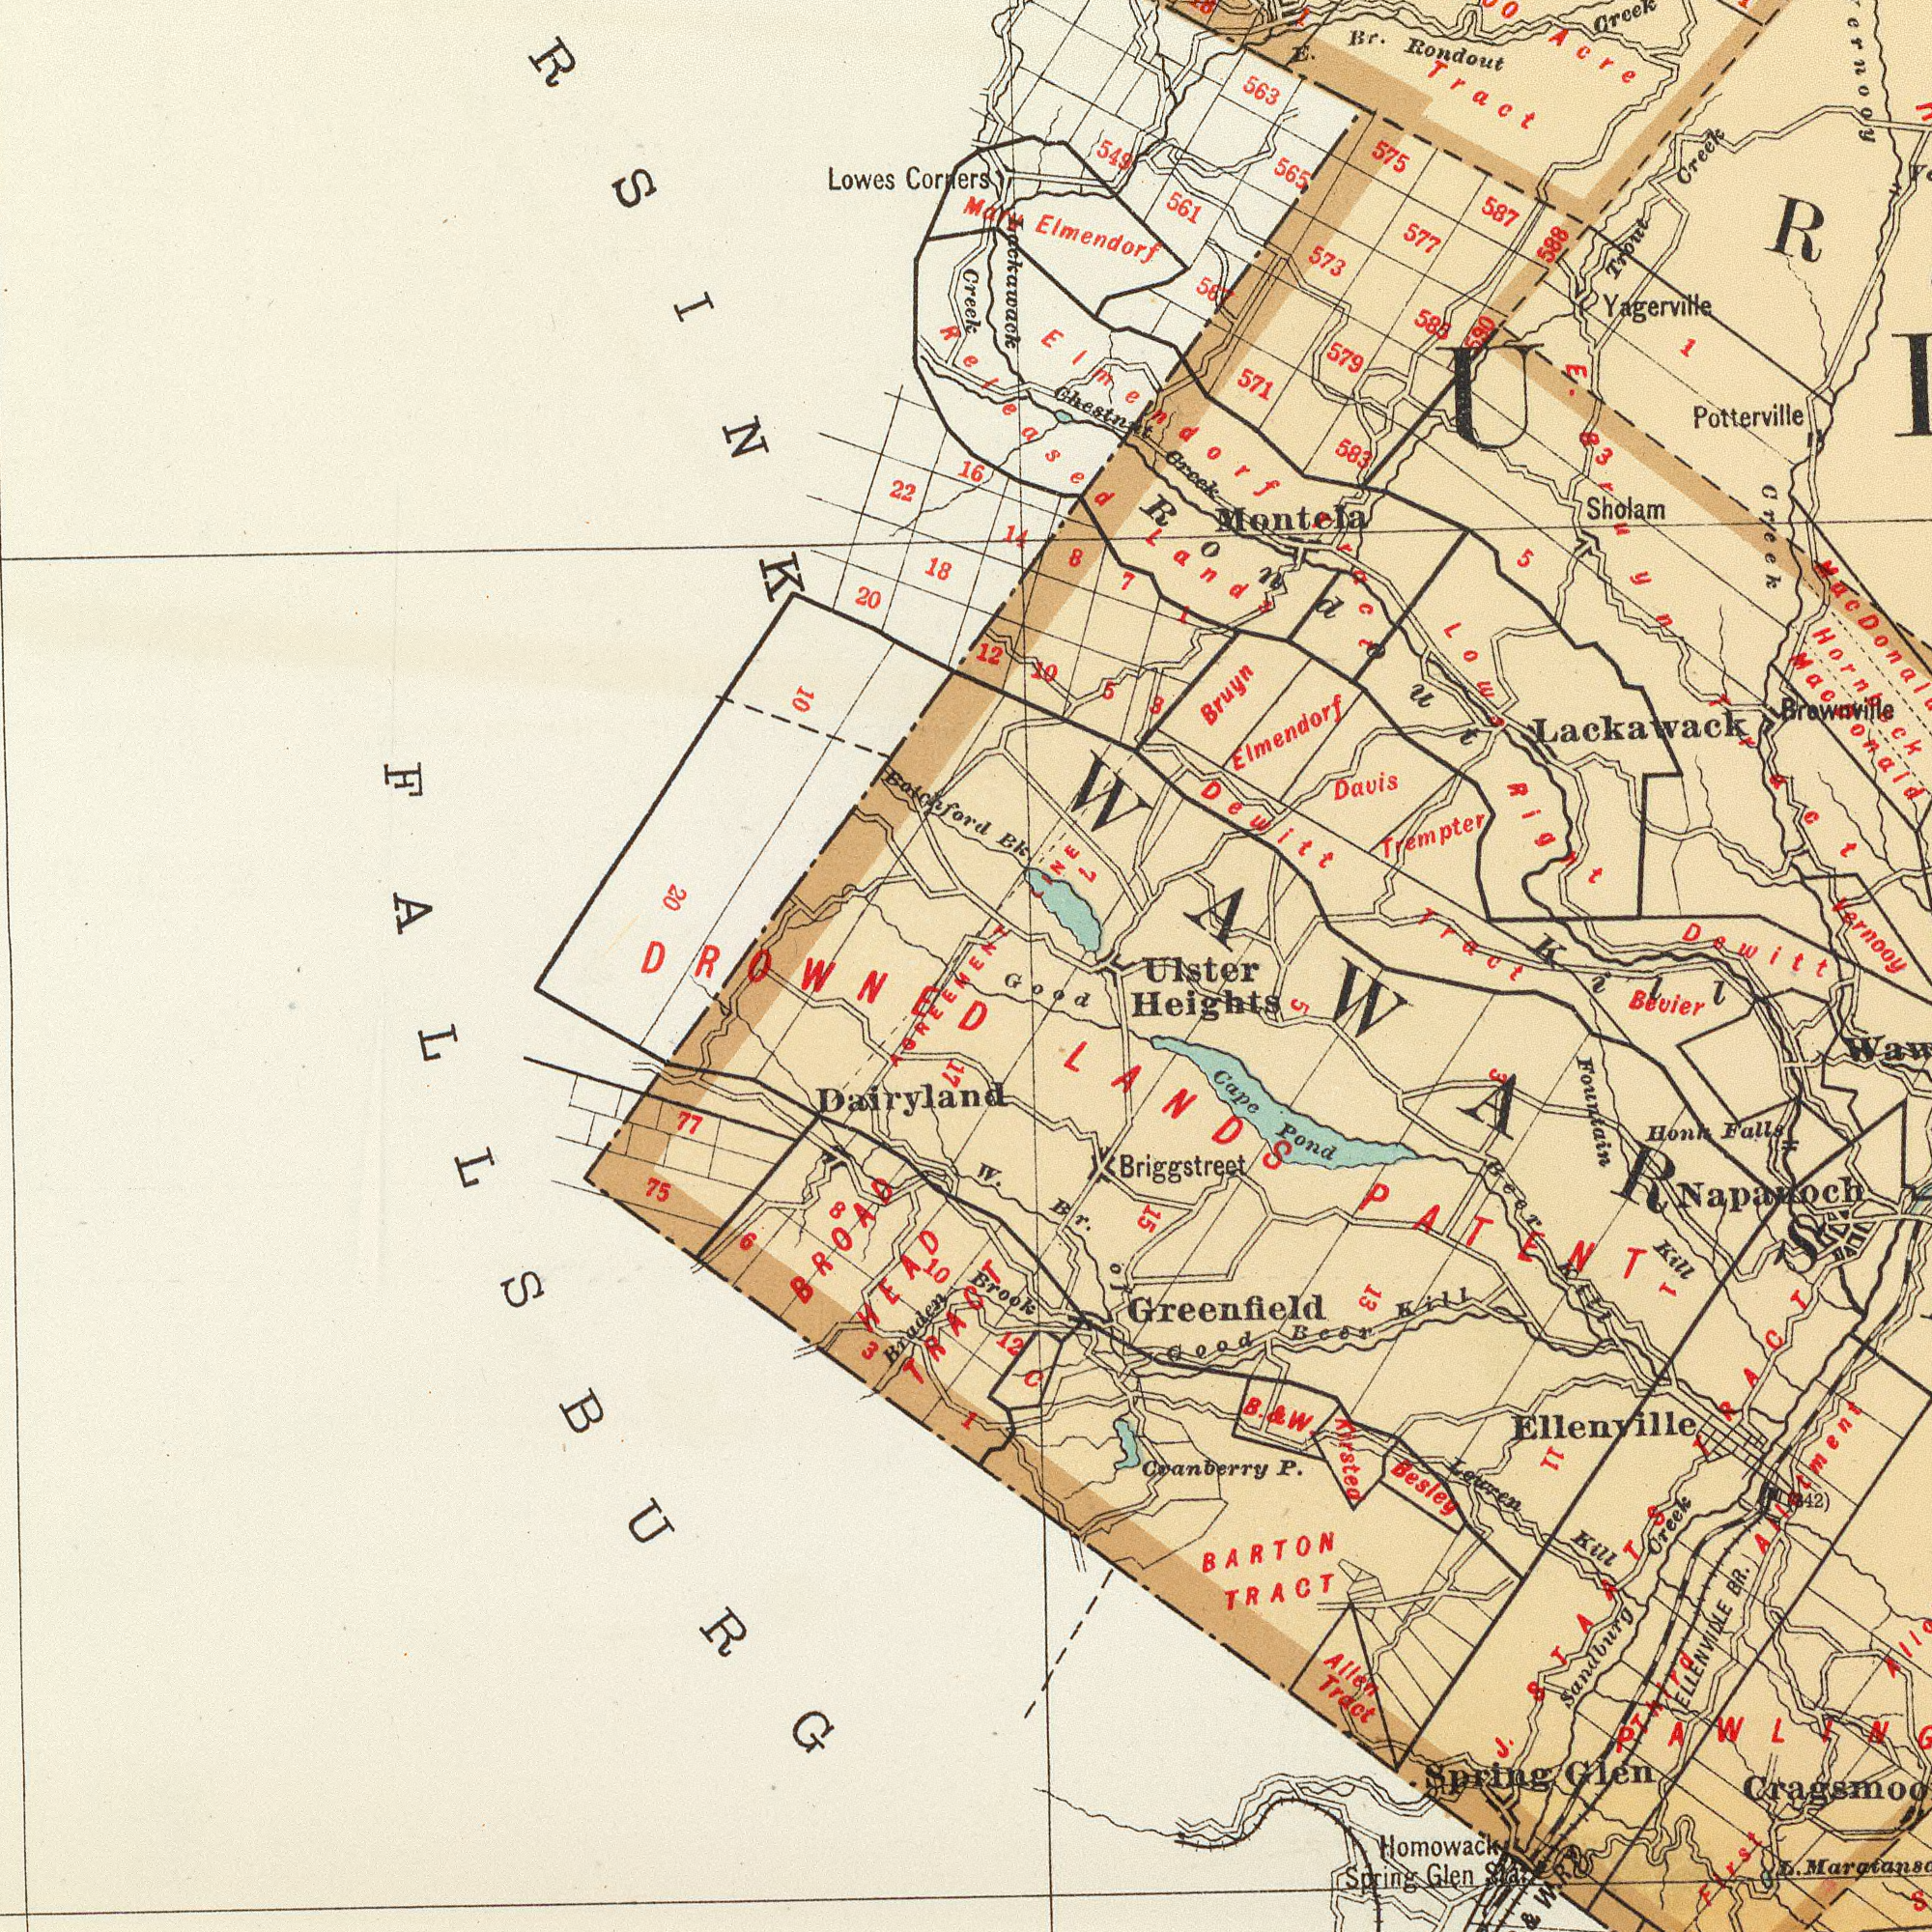What text appears in the bottom-left area of the image? Dairyland Braden Brook 75 77 BROAD HEAD TRACT 17 W. Br. Of 12 Good DROWNED C AGREEMENT 6 8 10 1 3 FALLSBURG What text can you see in the top-right section? Lackawack Dewitt Tract Potterville R Brawnville Trempter E. Br. Yagerville Rondout Creek Montela Davis Sholam 561 563 577 588 Trout Creek 587 583 Creek Creek Bruyn Vernooy 565 585 579 Acre Tract Elmendorf 573 567 Mac Donald 571 575 1 8 Lands E. Lows Right 690 5 Dewitt Bruyn Tract 1 Mac Elmendorf Tract Rondout I 3 What text appears in the bottom-right area of the image? BARTON TRACT Greenfield Honh Falls Napanoch Ellenville Allen Tract Cranberry P. Fountain Kill ELLENVIDLE BR. Besley Briggstreet Spring Glen Homowack Spring Glen Good Bear Kill Bevier Ahrstea Leuren Kill Sandburg Creek Beer Kill Ulster Heights Cape Pond J. STAATS TRACT 13 LANDS PATENT (42) L. Third Allotment Kill 5 15 1 First B. & W. 11 & W. R WAWARS 3 What text can you see in the top-left section? Lowes Corners 18 22 Batchford Bk. 20 10 Elmendorf 549 12 Lackawack Creek 8 10 14 5 Released 7 16 LNE L 20 RSINK 